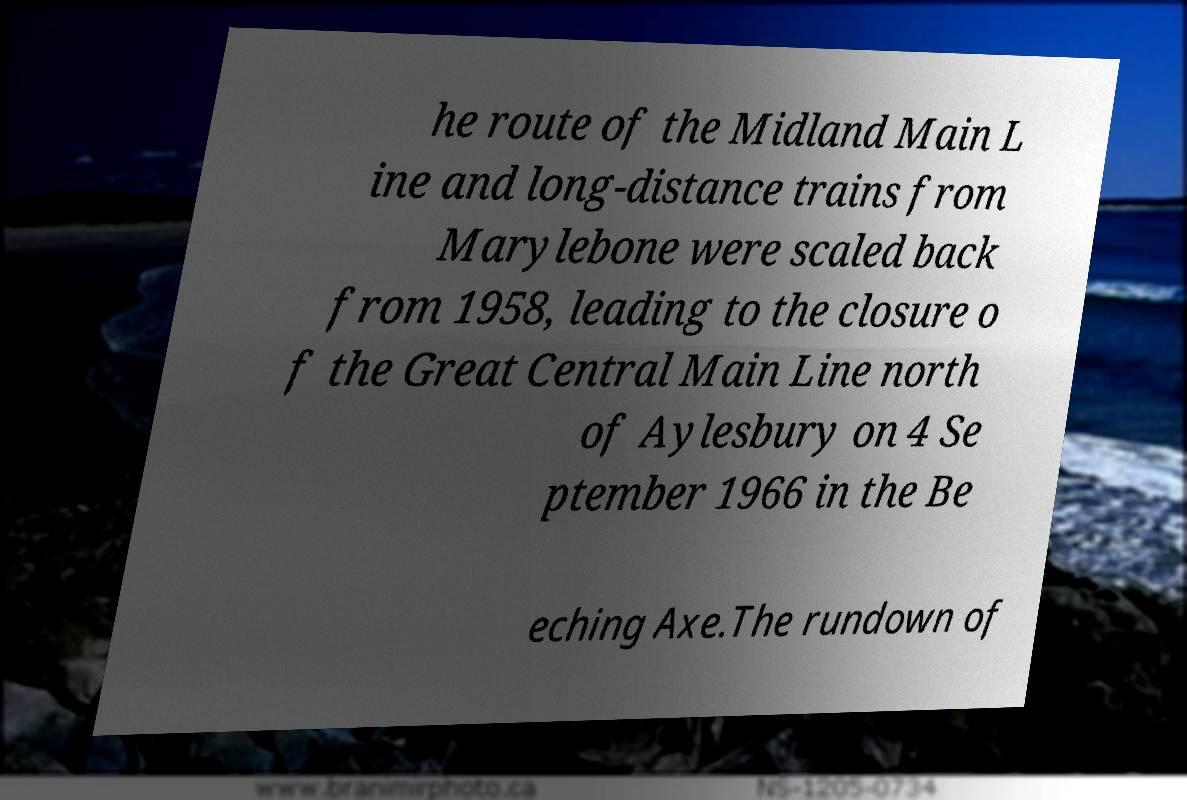Can you accurately transcribe the text from the provided image for me? he route of the Midland Main L ine and long-distance trains from Marylebone were scaled back from 1958, leading to the closure o f the Great Central Main Line north of Aylesbury on 4 Se ptember 1966 in the Be eching Axe.The rundown of 